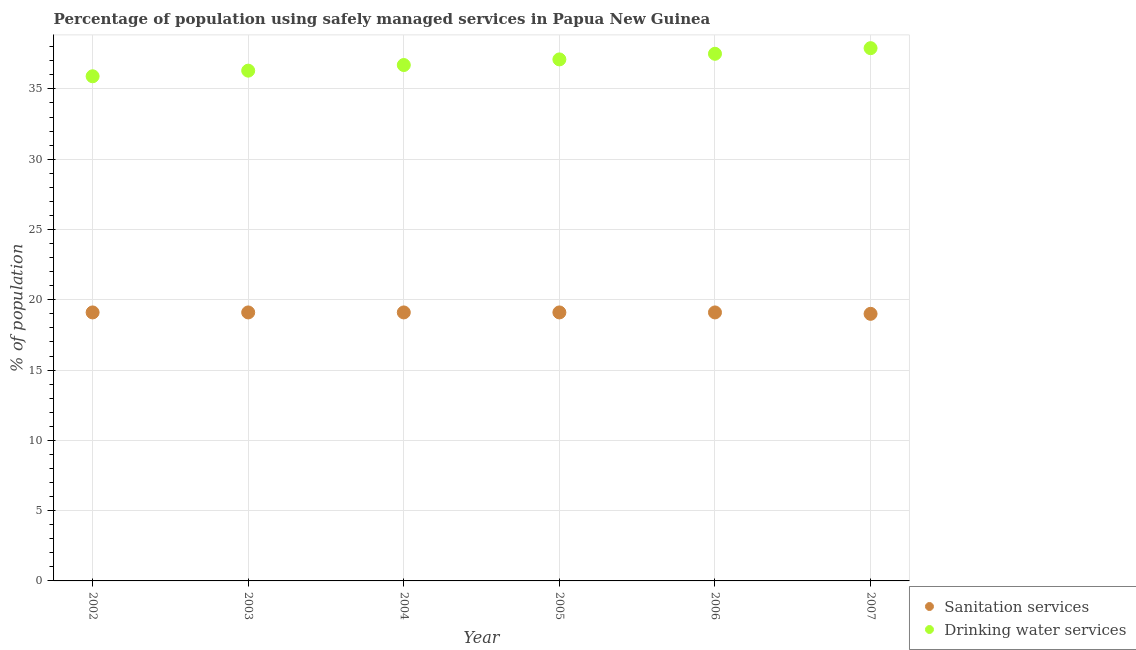Across all years, what is the maximum percentage of population who used drinking water services?
Give a very brief answer. 37.9. Across all years, what is the minimum percentage of population who used drinking water services?
Offer a very short reply. 35.9. In which year was the percentage of population who used sanitation services minimum?
Provide a short and direct response. 2007. What is the total percentage of population who used sanitation services in the graph?
Make the answer very short. 114.5. What is the difference between the percentage of population who used drinking water services in 2004 and that in 2007?
Ensure brevity in your answer.  -1.2. What is the difference between the percentage of population who used sanitation services in 2006 and the percentage of population who used drinking water services in 2002?
Provide a succinct answer. -16.8. What is the average percentage of population who used sanitation services per year?
Provide a succinct answer. 19.08. In the year 2002, what is the difference between the percentage of population who used drinking water services and percentage of population who used sanitation services?
Make the answer very short. 16.8. In how many years, is the percentage of population who used sanitation services greater than 35 %?
Make the answer very short. 0. What is the ratio of the percentage of population who used sanitation services in 2004 to that in 2006?
Your answer should be very brief. 1. Is the difference between the percentage of population who used drinking water services in 2006 and 2007 greater than the difference between the percentage of population who used sanitation services in 2006 and 2007?
Keep it short and to the point. No. What is the difference between the highest and the lowest percentage of population who used sanitation services?
Keep it short and to the point. 0.1. Is the sum of the percentage of population who used drinking water services in 2003 and 2004 greater than the maximum percentage of population who used sanitation services across all years?
Offer a very short reply. Yes. How many dotlines are there?
Your response must be concise. 2. Does the graph contain grids?
Keep it short and to the point. Yes. Where does the legend appear in the graph?
Your answer should be compact. Bottom right. How many legend labels are there?
Keep it short and to the point. 2. How are the legend labels stacked?
Your answer should be very brief. Vertical. What is the title of the graph?
Give a very brief answer. Percentage of population using safely managed services in Papua New Guinea. Does "Drinking water services" appear as one of the legend labels in the graph?
Your answer should be very brief. Yes. What is the label or title of the Y-axis?
Your answer should be very brief. % of population. What is the % of population of Drinking water services in 2002?
Ensure brevity in your answer.  35.9. What is the % of population of Drinking water services in 2003?
Provide a short and direct response. 36.3. What is the % of population in Drinking water services in 2004?
Ensure brevity in your answer.  36.7. What is the % of population in Drinking water services in 2005?
Ensure brevity in your answer.  37.1. What is the % of population of Drinking water services in 2006?
Your answer should be compact. 37.5. What is the % of population in Drinking water services in 2007?
Provide a short and direct response. 37.9. Across all years, what is the maximum % of population of Sanitation services?
Make the answer very short. 19.1. Across all years, what is the maximum % of population in Drinking water services?
Keep it short and to the point. 37.9. Across all years, what is the minimum % of population of Drinking water services?
Your answer should be very brief. 35.9. What is the total % of population in Sanitation services in the graph?
Make the answer very short. 114.5. What is the total % of population in Drinking water services in the graph?
Keep it short and to the point. 221.4. What is the difference between the % of population of Sanitation services in 2002 and that in 2004?
Give a very brief answer. 0. What is the difference between the % of population in Sanitation services in 2002 and that in 2005?
Make the answer very short. 0. What is the difference between the % of population of Drinking water services in 2002 and that in 2006?
Your response must be concise. -1.6. What is the difference between the % of population in Drinking water services in 2002 and that in 2007?
Keep it short and to the point. -2. What is the difference between the % of population of Sanitation services in 2003 and that in 2004?
Your answer should be compact. 0. What is the difference between the % of population in Sanitation services in 2003 and that in 2006?
Offer a very short reply. 0. What is the difference between the % of population of Drinking water services in 2003 and that in 2006?
Provide a short and direct response. -1.2. What is the difference between the % of population in Sanitation services in 2003 and that in 2007?
Your response must be concise. 0.1. What is the difference between the % of population in Drinking water services in 2003 and that in 2007?
Provide a short and direct response. -1.6. What is the difference between the % of population in Sanitation services in 2004 and that in 2005?
Your answer should be very brief. 0. What is the difference between the % of population of Drinking water services in 2004 and that in 2005?
Offer a terse response. -0.4. What is the difference between the % of population in Sanitation services in 2004 and that in 2006?
Provide a short and direct response. 0. What is the difference between the % of population of Drinking water services in 2004 and that in 2006?
Give a very brief answer. -0.8. What is the difference between the % of population in Sanitation services in 2004 and that in 2007?
Your answer should be very brief. 0.1. What is the difference between the % of population of Drinking water services in 2004 and that in 2007?
Provide a succinct answer. -1.2. What is the difference between the % of population of Drinking water services in 2005 and that in 2007?
Offer a very short reply. -0.8. What is the difference between the % of population in Drinking water services in 2006 and that in 2007?
Provide a short and direct response. -0.4. What is the difference between the % of population of Sanitation services in 2002 and the % of population of Drinking water services in 2003?
Ensure brevity in your answer.  -17.2. What is the difference between the % of population in Sanitation services in 2002 and the % of population in Drinking water services in 2004?
Your response must be concise. -17.6. What is the difference between the % of population in Sanitation services in 2002 and the % of population in Drinking water services in 2005?
Give a very brief answer. -18. What is the difference between the % of population of Sanitation services in 2002 and the % of population of Drinking water services in 2006?
Provide a short and direct response. -18.4. What is the difference between the % of population in Sanitation services in 2002 and the % of population in Drinking water services in 2007?
Offer a terse response. -18.8. What is the difference between the % of population of Sanitation services in 2003 and the % of population of Drinking water services in 2004?
Give a very brief answer. -17.6. What is the difference between the % of population in Sanitation services in 2003 and the % of population in Drinking water services in 2006?
Offer a terse response. -18.4. What is the difference between the % of population in Sanitation services in 2003 and the % of population in Drinking water services in 2007?
Provide a succinct answer. -18.8. What is the difference between the % of population of Sanitation services in 2004 and the % of population of Drinking water services in 2006?
Give a very brief answer. -18.4. What is the difference between the % of population in Sanitation services in 2004 and the % of population in Drinking water services in 2007?
Make the answer very short. -18.8. What is the difference between the % of population in Sanitation services in 2005 and the % of population in Drinking water services in 2006?
Provide a short and direct response. -18.4. What is the difference between the % of population in Sanitation services in 2005 and the % of population in Drinking water services in 2007?
Offer a very short reply. -18.8. What is the difference between the % of population in Sanitation services in 2006 and the % of population in Drinking water services in 2007?
Give a very brief answer. -18.8. What is the average % of population of Sanitation services per year?
Offer a very short reply. 19.08. What is the average % of population in Drinking water services per year?
Make the answer very short. 36.9. In the year 2002, what is the difference between the % of population in Sanitation services and % of population in Drinking water services?
Provide a succinct answer. -16.8. In the year 2003, what is the difference between the % of population of Sanitation services and % of population of Drinking water services?
Make the answer very short. -17.2. In the year 2004, what is the difference between the % of population in Sanitation services and % of population in Drinking water services?
Ensure brevity in your answer.  -17.6. In the year 2005, what is the difference between the % of population in Sanitation services and % of population in Drinking water services?
Keep it short and to the point. -18. In the year 2006, what is the difference between the % of population in Sanitation services and % of population in Drinking water services?
Keep it short and to the point. -18.4. In the year 2007, what is the difference between the % of population of Sanitation services and % of population of Drinking water services?
Provide a short and direct response. -18.9. What is the ratio of the % of population in Sanitation services in 2002 to that in 2003?
Provide a short and direct response. 1. What is the ratio of the % of population of Drinking water services in 2002 to that in 2003?
Make the answer very short. 0.99. What is the ratio of the % of population in Drinking water services in 2002 to that in 2004?
Ensure brevity in your answer.  0.98. What is the ratio of the % of population in Sanitation services in 2002 to that in 2006?
Offer a terse response. 1. What is the ratio of the % of population of Drinking water services in 2002 to that in 2006?
Keep it short and to the point. 0.96. What is the ratio of the % of population of Drinking water services in 2002 to that in 2007?
Give a very brief answer. 0.95. What is the ratio of the % of population of Drinking water services in 2003 to that in 2004?
Keep it short and to the point. 0.99. What is the ratio of the % of population in Sanitation services in 2003 to that in 2005?
Make the answer very short. 1. What is the ratio of the % of population in Drinking water services in 2003 to that in 2005?
Provide a succinct answer. 0.98. What is the ratio of the % of population in Drinking water services in 2003 to that in 2007?
Keep it short and to the point. 0.96. What is the ratio of the % of population of Drinking water services in 2004 to that in 2006?
Give a very brief answer. 0.98. What is the ratio of the % of population of Sanitation services in 2004 to that in 2007?
Ensure brevity in your answer.  1.01. What is the ratio of the % of population of Drinking water services in 2004 to that in 2007?
Offer a terse response. 0.97. What is the ratio of the % of population in Sanitation services in 2005 to that in 2006?
Provide a short and direct response. 1. What is the ratio of the % of population in Drinking water services in 2005 to that in 2006?
Provide a short and direct response. 0.99. What is the ratio of the % of population of Drinking water services in 2005 to that in 2007?
Ensure brevity in your answer.  0.98. What is the ratio of the % of population of Sanitation services in 2006 to that in 2007?
Keep it short and to the point. 1.01. What is the ratio of the % of population of Drinking water services in 2006 to that in 2007?
Make the answer very short. 0.99. What is the difference between the highest and the second highest % of population in Sanitation services?
Ensure brevity in your answer.  0. What is the difference between the highest and the lowest % of population of Sanitation services?
Provide a succinct answer. 0.1. 